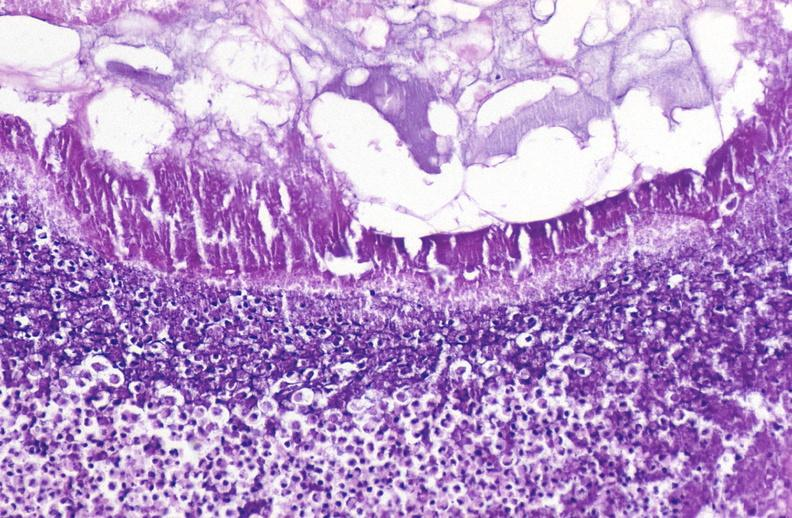what does this image show?
Answer the question using a single word or phrase. Pancreatic fat necrosis 